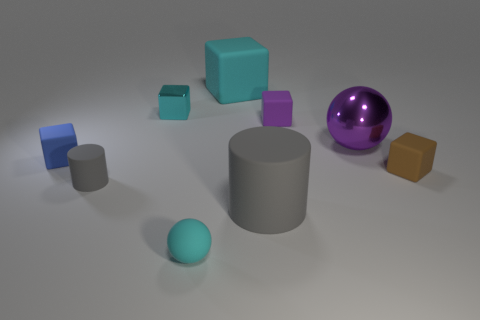Subtract all purple cubes. How many cubes are left? 4 Subtract all big blocks. How many blocks are left? 4 Add 1 small rubber balls. How many objects exist? 10 Subtract all red cubes. Subtract all green spheres. How many cubes are left? 5 Subtract all balls. How many objects are left? 7 Add 7 purple objects. How many purple objects are left? 9 Add 9 blue things. How many blue things exist? 10 Subtract 0 green cubes. How many objects are left? 9 Subtract all gray shiny cylinders. Subtract all tiny metal objects. How many objects are left? 8 